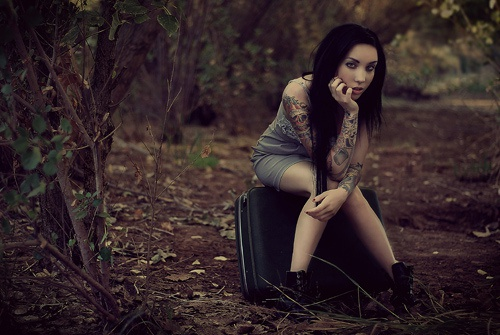Describe the objects in this image and their specific colors. I can see people in black, gray, and tan tones and suitcase in black and gray tones in this image. 